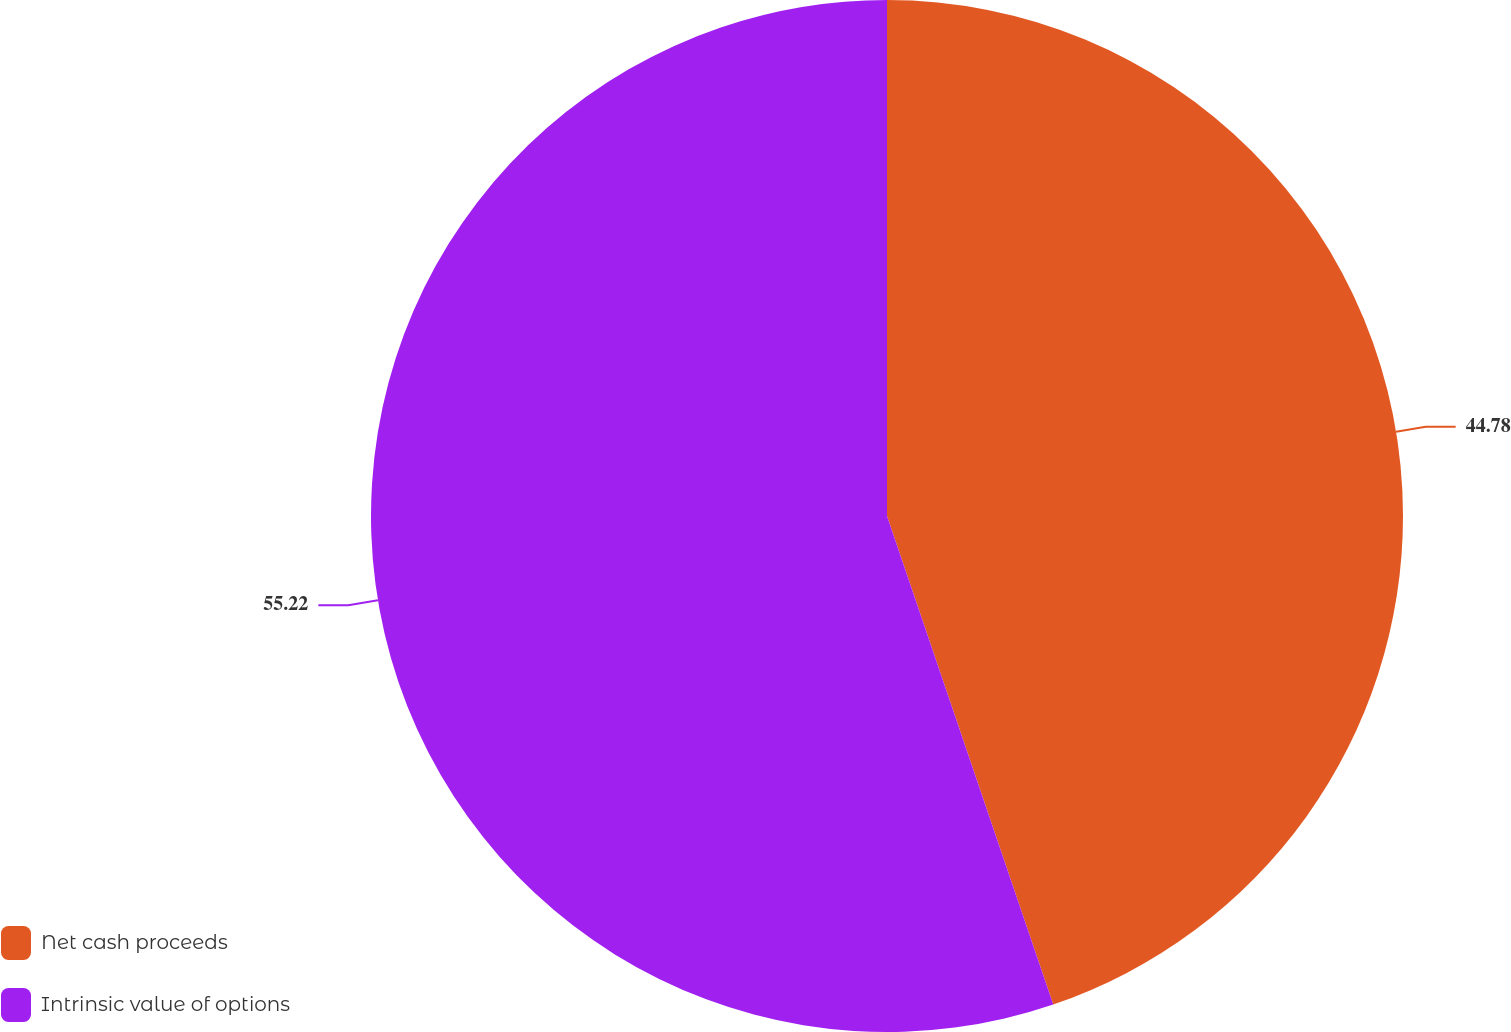<chart> <loc_0><loc_0><loc_500><loc_500><pie_chart><fcel>Net cash proceeds<fcel>Intrinsic value of options<nl><fcel>44.78%<fcel>55.22%<nl></chart> 